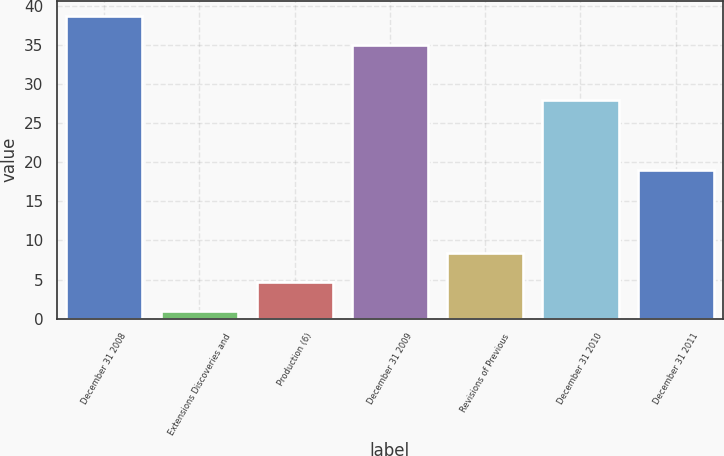Convert chart to OTSL. <chart><loc_0><loc_0><loc_500><loc_500><bar_chart><fcel>December 31 2008<fcel>Extensions Discoveries and<fcel>Production (6)<fcel>December 31 2009<fcel>Revisions of Previous<fcel>December 31 2010<fcel>December 31 2011<nl><fcel>38.7<fcel>1<fcel>4.7<fcel>35<fcel>8.4<fcel>28<fcel>19<nl></chart> 